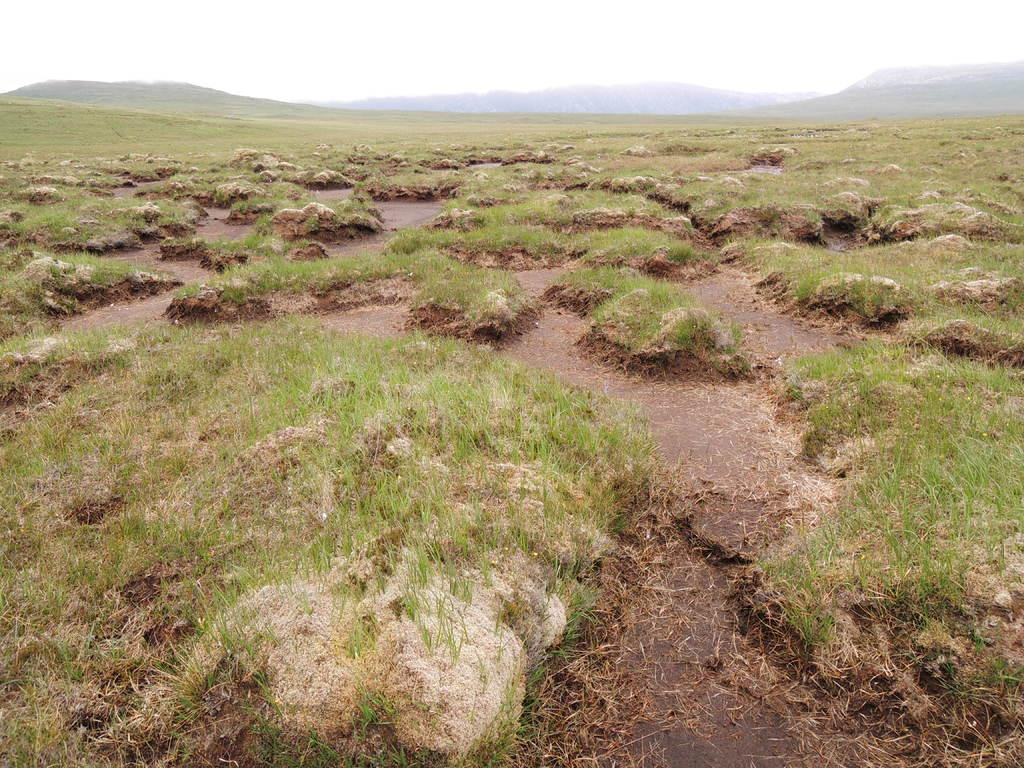What type of terrain is depicted in the image? A: The image contains soil and grass. What can be seen in the background of the image? There are hills in the background of the image. What is visible at the top of the image? The sky is visible at the top of the image. What type of pan is being used to attack the hills in the image? There is no pan or any form of attack present in the image. The image simply depicts a landscape with soil, grass, hills, and the sky. 